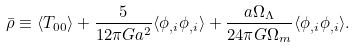<formula> <loc_0><loc_0><loc_500><loc_500>\bar { \rho } \equiv \langle { T _ { 0 0 } } \rangle + \frac { 5 } { 1 2 \pi G a ^ { 2 } } \langle { \phi _ { , i } \phi _ { , i } } \rangle + \frac { a \Omega _ { \Lambda } } { 2 4 \pi G \Omega _ { m } } \langle { \phi _ { , i } \phi _ { , i } } \rangle .</formula> 